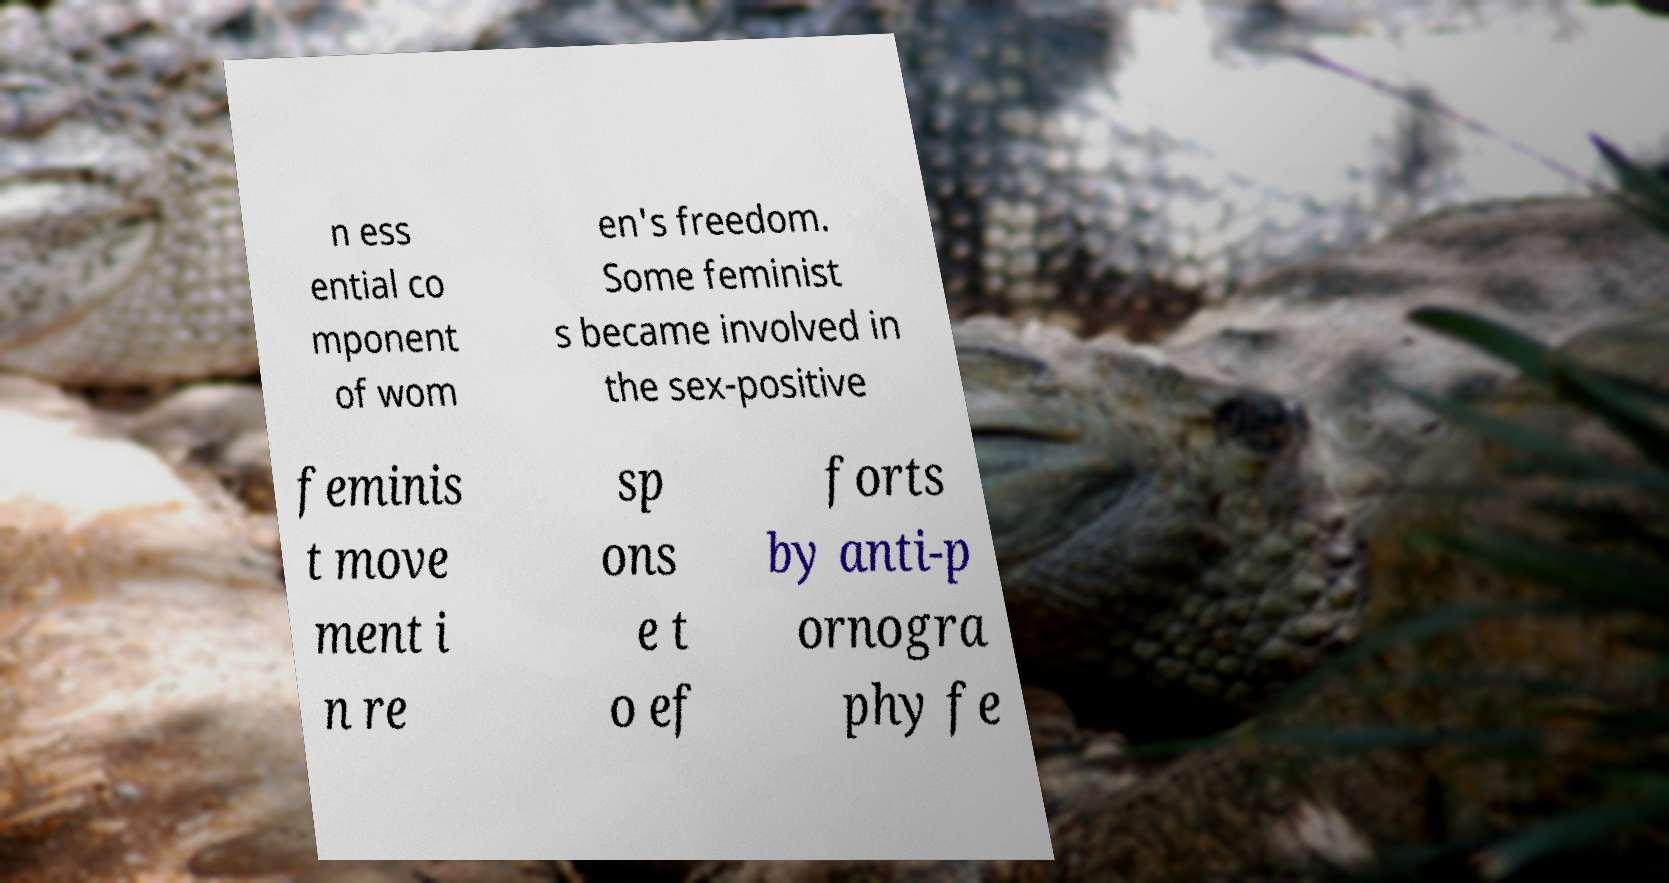I need the written content from this picture converted into text. Can you do that? n ess ential co mponent of wom en's freedom. Some feminist s became involved in the sex-positive feminis t move ment i n re sp ons e t o ef forts by anti-p ornogra phy fe 